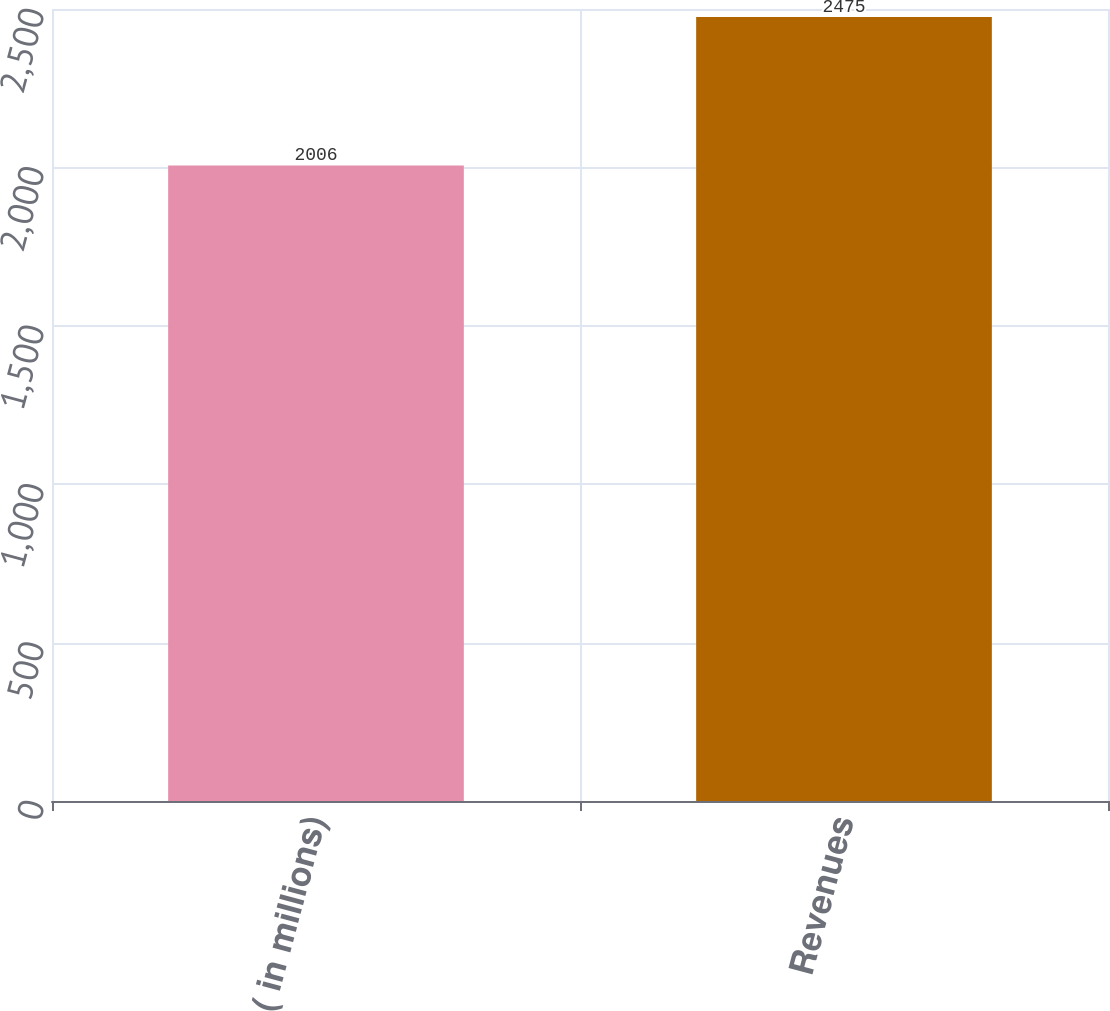Convert chart. <chart><loc_0><loc_0><loc_500><loc_500><bar_chart><fcel>( in millions)<fcel>Revenues<nl><fcel>2006<fcel>2475<nl></chart> 